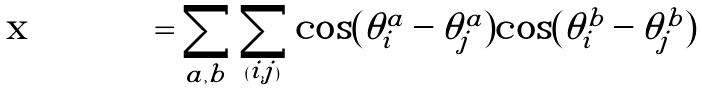<formula> <loc_0><loc_0><loc_500><loc_500>= \sum _ { a , b } { \sum _ { ( i , j ) } \cos ( \theta _ { i } ^ { a } - \theta _ { j } ^ { a } ) \cos ( \theta _ { i } ^ { b } - \theta _ { j } ^ { b } ) }</formula> 